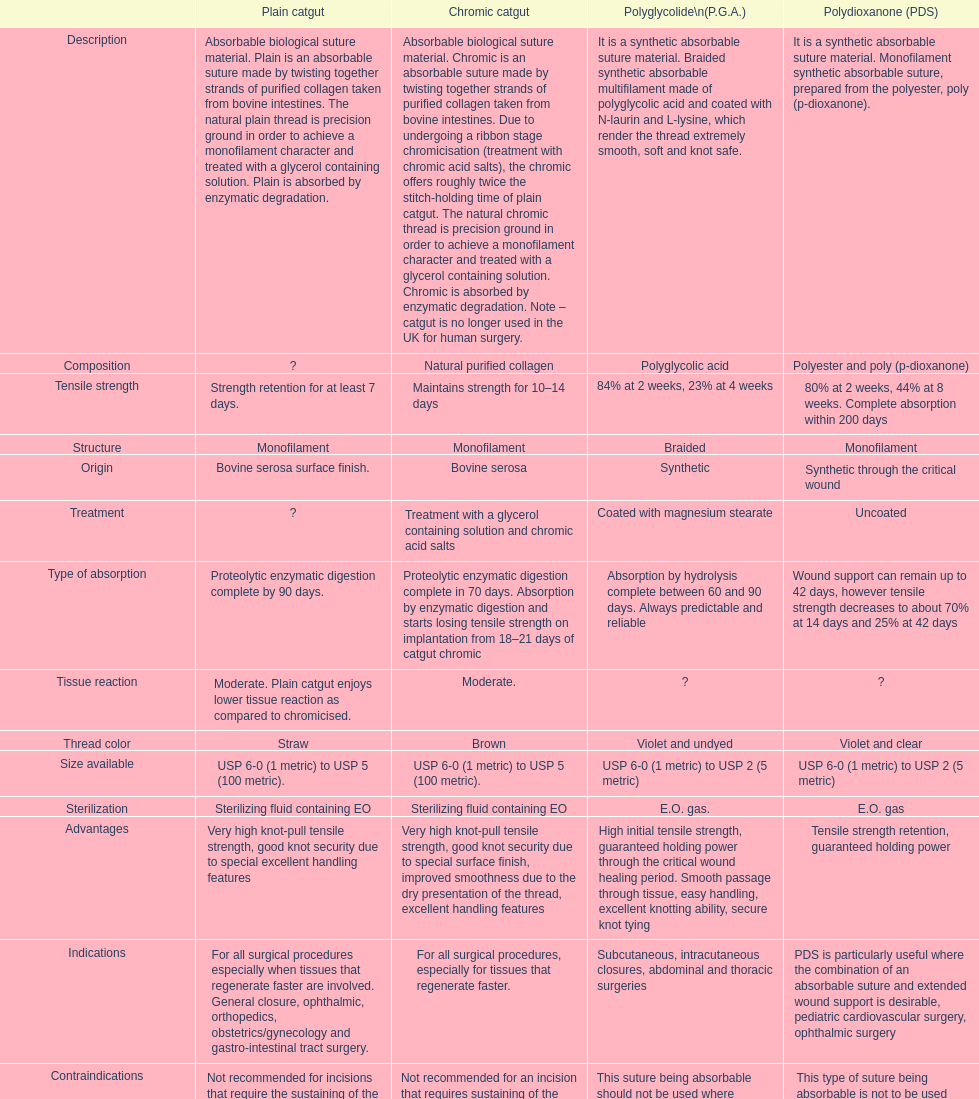Which type of suture can last up to a maximum of 42 days? Polydioxanone (PDS). 